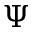Convert formula to latex. <formula><loc_0><loc_0><loc_500><loc_500>\Psi</formula> 